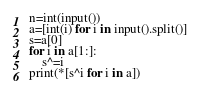Convert code to text. <code><loc_0><loc_0><loc_500><loc_500><_Python_>n=int(input())
a=[int(i) for i in input().split()]
s=a[0]
for i in a[1:]:
    s^=i
print(*[s^i for i in a])</code> 